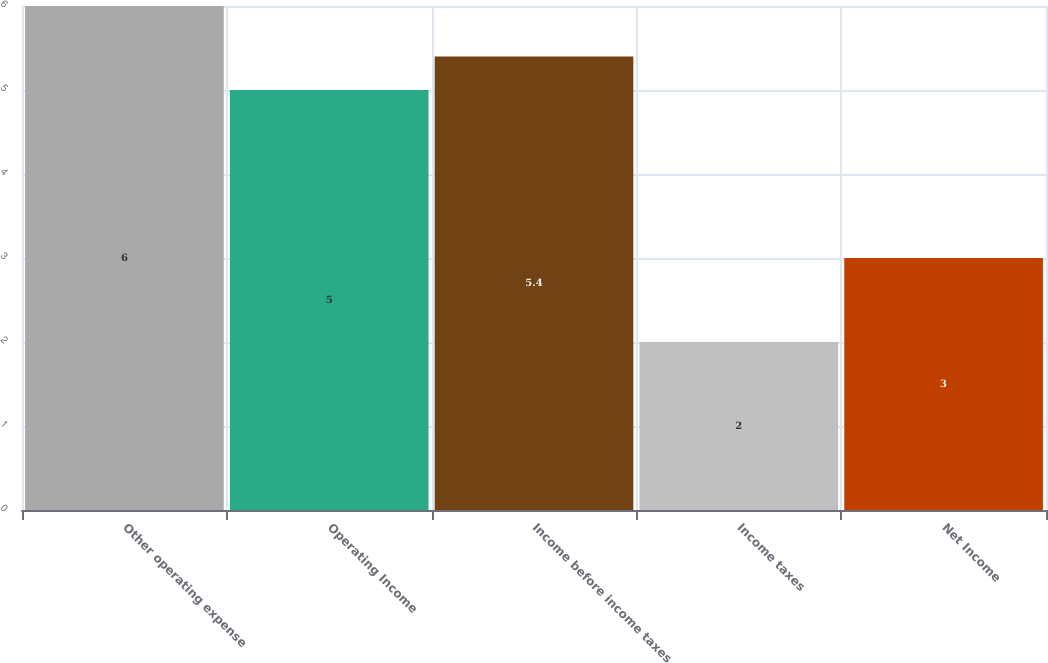Convert chart. <chart><loc_0><loc_0><loc_500><loc_500><bar_chart><fcel>Other operating expense<fcel>Operating Income<fcel>Income before income taxes<fcel>Income taxes<fcel>Net Income<nl><fcel>6<fcel>5<fcel>5.4<fcel>2<fcel>3<nl></chart> 